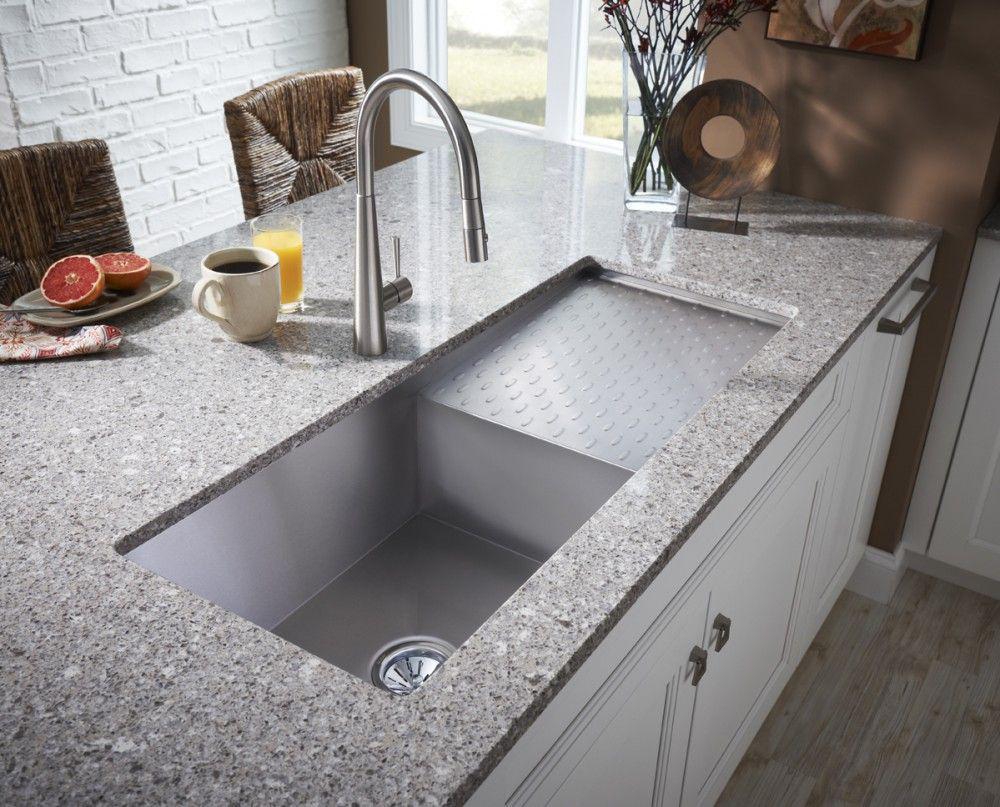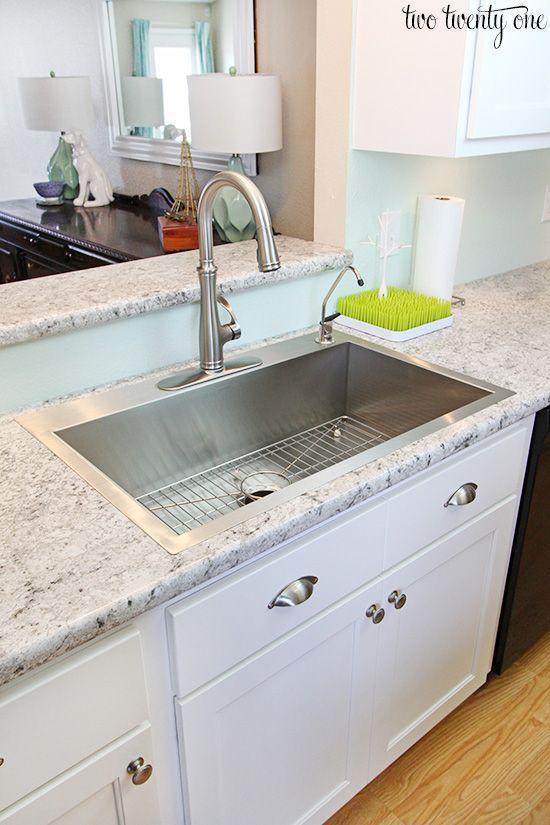The first image is the image on the left, the second image is the image on the right. Given the left and right images, does the statement "A large sink is surrounded by a marbled countertop." hold true? Answer yes or no. Yes. 